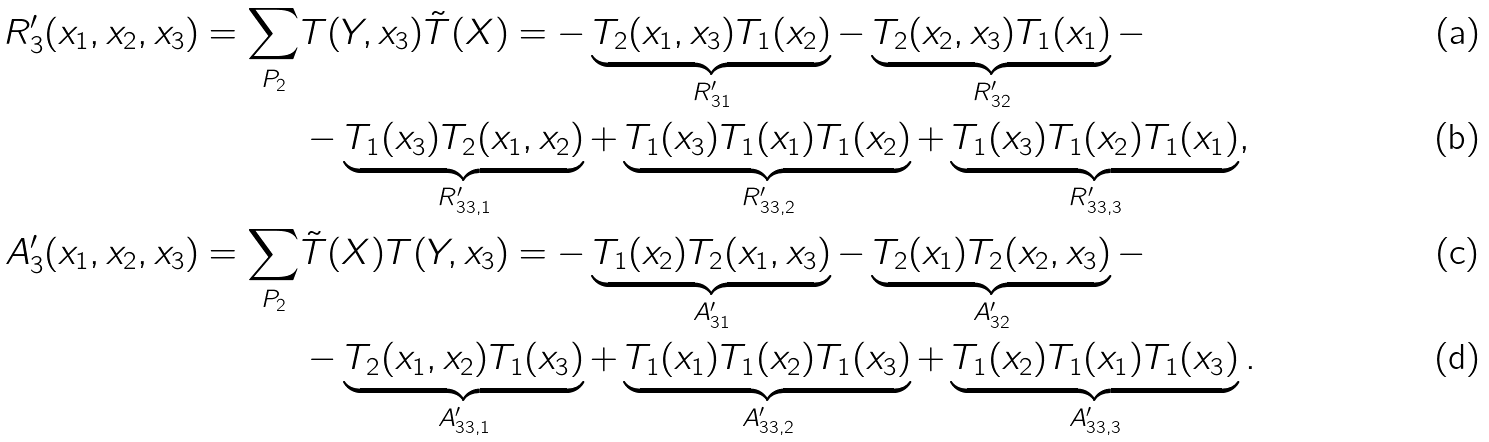<formula> <loc_0><loc_0><loc_500><loc_500>R _ { 3 } ^ { \prime } ( x _ { 1 } , x _ { 2 } , x _ { 3 } ) = \sum _ { P _ { 2 } } & T ( Y , x _ { 3 } ) \tilde { T } ( X ) = - \underbrace { T _ { 2 } ( x _ { 1 } , x _ { 3 } ) T _ { 1 } ( x _ { 2 } ) } _ { R _ { 3 1 } ^ { \prime } } - \underbrace { T _ { 2 } ( x _ { 2 } , x _ { 3 } ) T _ { 1 } ( x _ { 1 } ) } _ { R _ { 3 2 } ^ { \prime } } - \\ & - \underbrace { T _ { 1 } ( x _ { 3 } ) T _ { 2 } ( x _ { 1 } , x _ { 2 } ) } _ { R _ { 3 3 , 1 } ^ { \prime } } + \underbrace { T _ { 1 } ( x _ { 3 } ) T _ { 1 } ( x _ { 1 } ) T _ { 1 } ( x _ { 2 } ) } _ { R _ { 3 3 , 2 } ^ { \prime } } + \underbrace { T _ { 1 } ( x _ { 3 } ) T _ { 1 } ( x _ { 2 } ) T _ { 1 } ( x _ { 1 } ) } _ { R _ { 3 3 , 3 } ^ { \prime } } , \\ A _ { 3 } ^ { \prime } ( x _ { 1 } , x _ { 2 } , x _ { 3 } ) = \sum _ { P _ { 2 } } & \tilde { T } ( X ) T ( Y , x _ { 3 } ) = - \underbrace { T _ { 1 } ( x _ { 2 } ) T _ { 2 } ( x _ { 1 } , x _ { 3 } ) } _ { A _ { 3 1 } ^ { \prime } } - \underbrace { T _ { 2 } ( x _ { 1 } ) T _ { 2 } ( x _ { 2 } , x _ { 3 } ) } _ { A _ { 3 2 } ^ { \prime } } - \\ & - \underbrace { T _ { 2 } ( x _ { 1 } , x _ { 2 } ) T _ { 1 } ( x _ { 3 } ) } _ { A _ { 3 3 , 1 } ^ { \prime } } + \underbrace { T _ { 1 } ( x _ { 1 } ) T _ { 1 } ( x _ { 2 } ) T _ { 1 } ( x _ { 3 } ) } _ { A _ { 3 3 , 2 } ^ { \prime } } + \underbrace { T _ { 1 } ( x _ { 2 } ) T _ { 1 } ( x _ { 1 } ) T _ { 1 } ( x _ { 3 } ) } _ { A _ { 3 3 , 3 } ^ { \prime } } .</formula> 